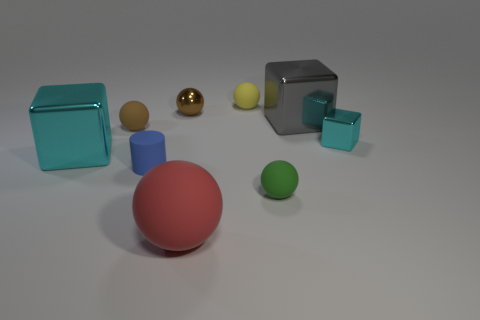Is the shape of the brown metal thing the same as the cyan metallic object that is in front of the tiny cyan block?
Make the answer very short. No. There is a tiny thing that is both right of the big red thing and behind the gray thing; what material is it?
Your answer should be compact. Rubber. There is a block that is the same size as the green rubber sphere; what color is it?
Offer a terse response. Cyan. Does the large cyan block have the same material as the sphere that is to the left of the brown shiny object?
Keep it short and to the point. No. What number of other things are the same size as the red ball?
Keep it short and to the point. 2. Is there a large gray metallic thing in front of the cyan block on the right side of the tiny ball behind the tiny brown shiny thing?
Provide a short and direct response. No. How big is the blue rubber thing?
Your answer should be compact. Small. What is the size of the cyan cube that is to the right of the metal sphere?
Ensure brevity in your answer.  Small. Do the ball in front of the green matte ball and the green thing have the same size?
Offer a very short reply. No. Are there any other things that are the same color as the tiny shiny cube?
Offer a terse response. Yes. 